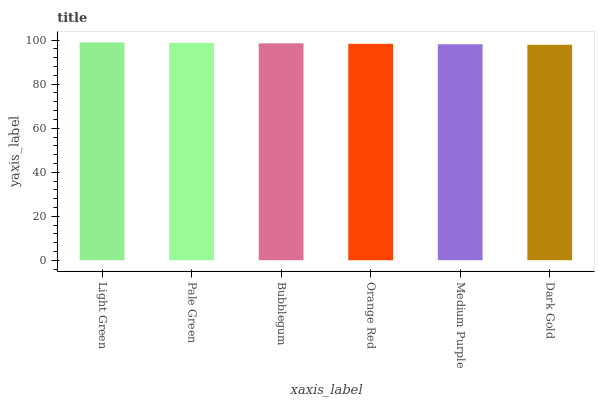Is Dark Gold the minimum?
Answer yes or no. Yes. Is Light Green the maximum?
Answer yes or no. Yes. Is Pale Green the minimum?
Answer yes or no. No. Is Pale Green the maximum?
Answer yes or no. No. Is Light Green greater than Pale Green?
Answer yes or no. Yes. Is Pale Green less than Light Green?
Answer yes or no. Yes. Is Pale Green greater than Light Green?
Answer yes or no. No. Is Light Green less than Pale Green?
Answer yes or no. No. Is Bubblegum the high median?
Answer yes or no. Yes. Is Orange Red the low median?
Answer yes or no. Yes. Is Pale Green the high median?
Answer yes or no. No. Is Pale Green the low median?
Answer yes or no. No. 